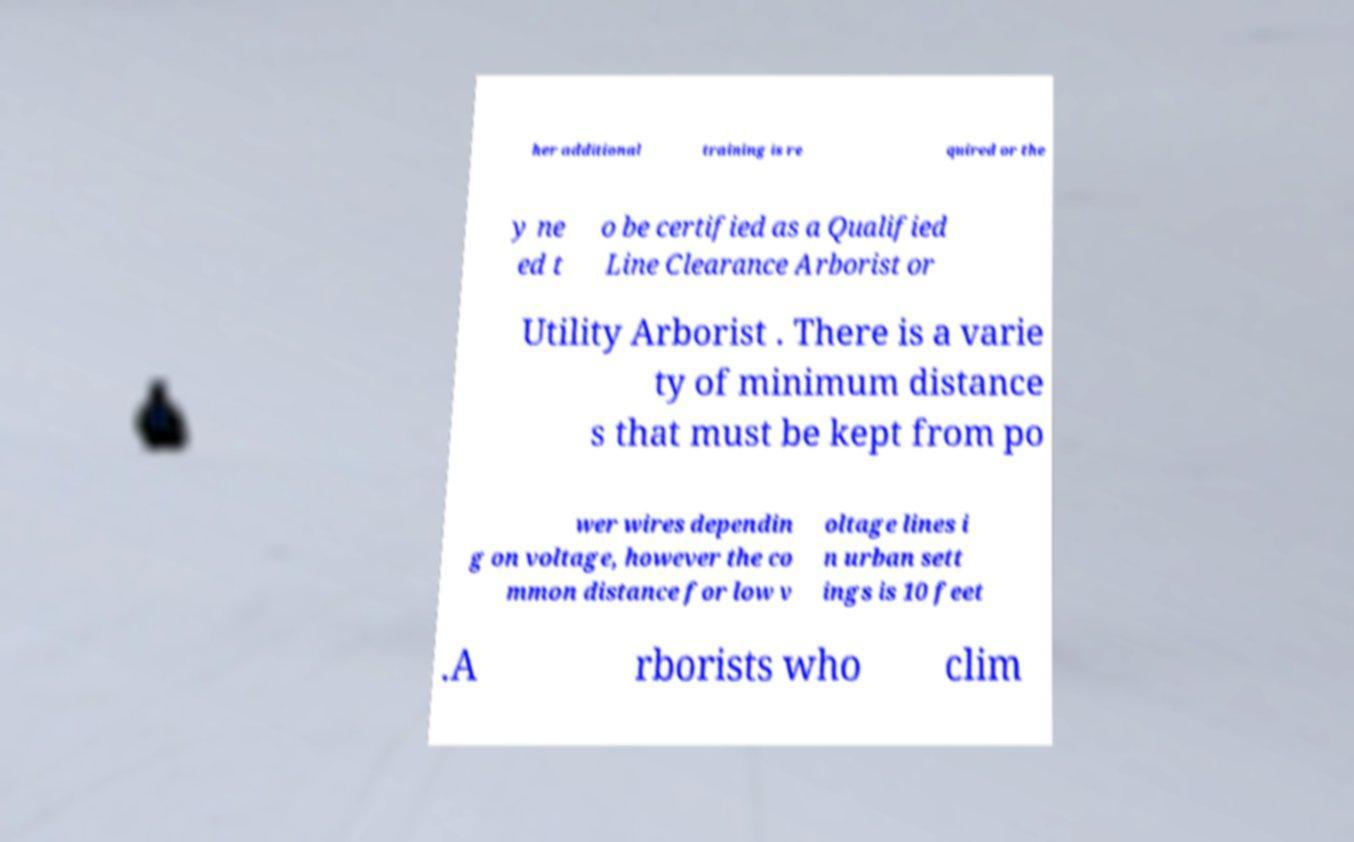I need the written content from this picture converted into text. Can you do that? her additional training is re quired or the y ne ed t o be certified as a Qualified Line Clearance Arborist or Utility Arborist . There is a varie ty of minimum distance s that must be kept from po wer wires dependin g on voltage, however the co mmon distance for low v oltage lines i n urban sett ings is 10 feet .A rborists who clim 